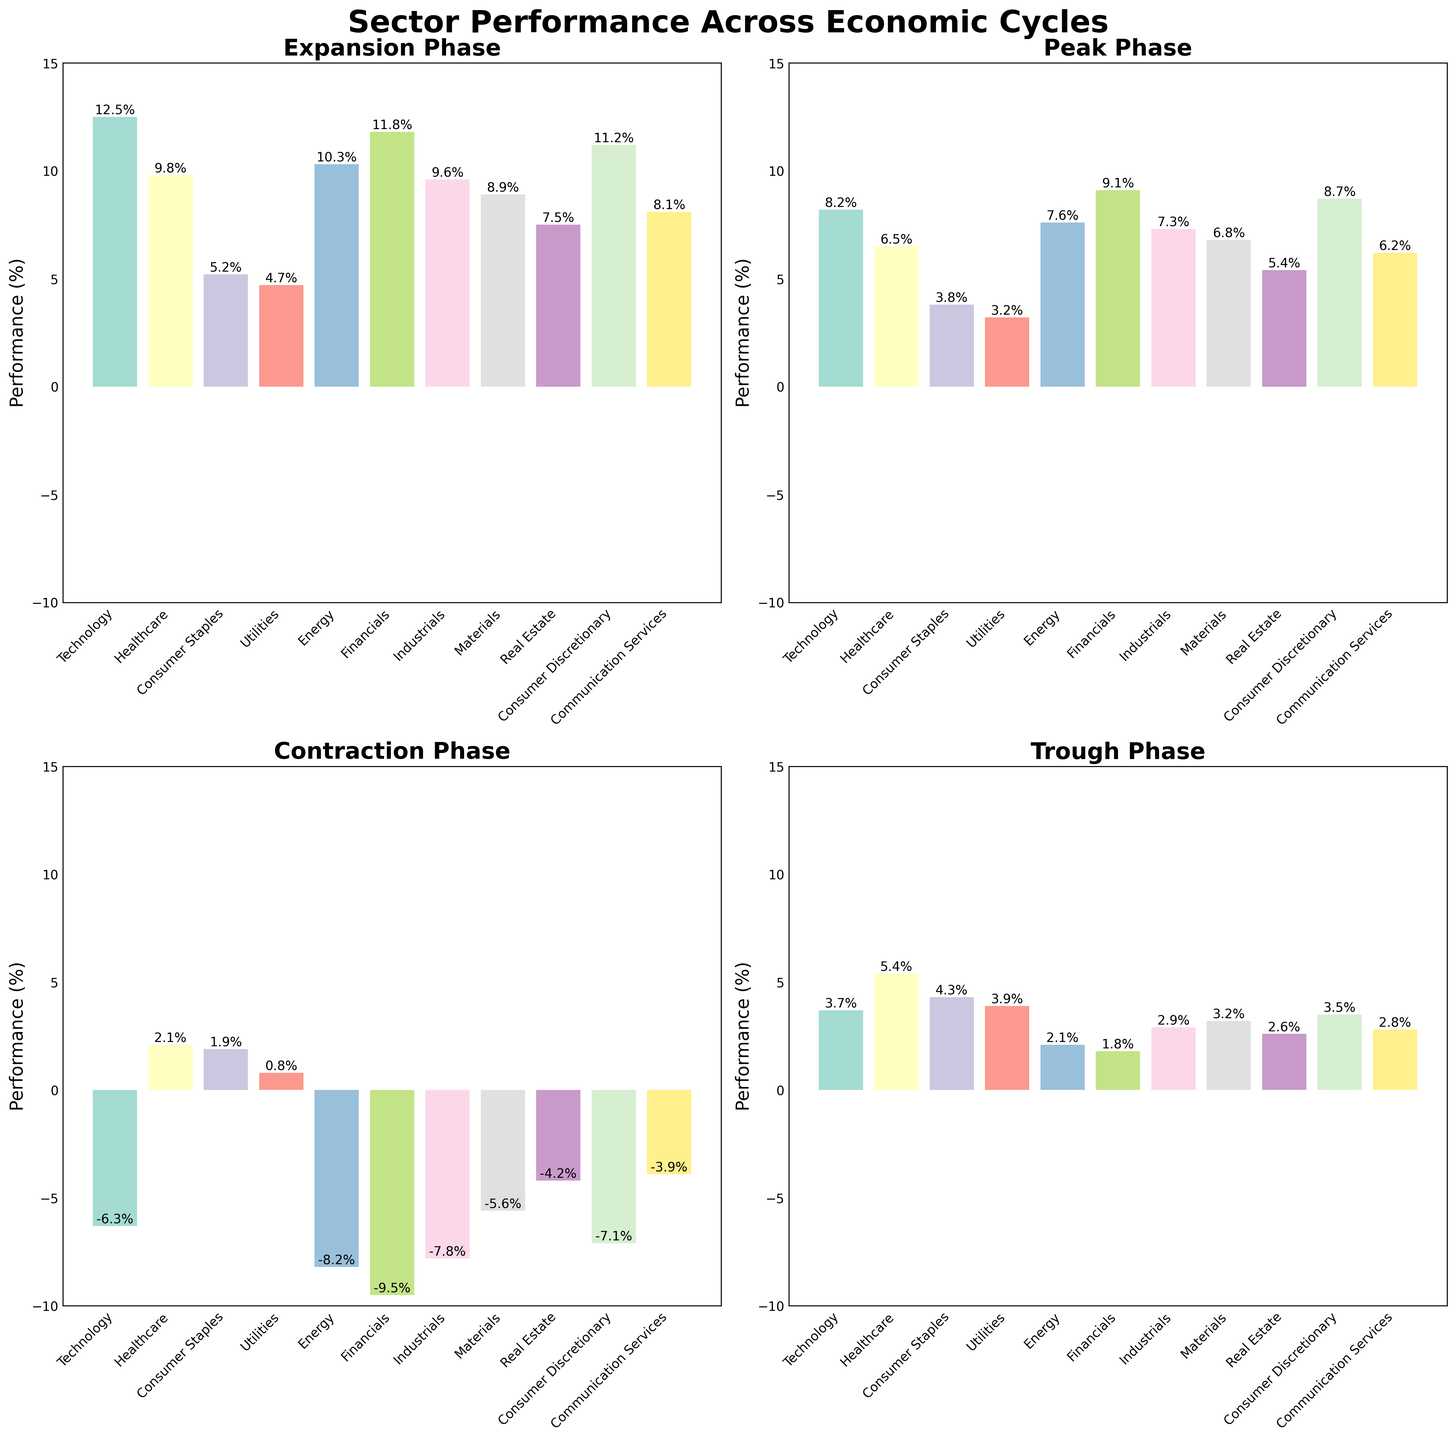Which sector performs the best during the Expansion phase? Look at the bar heights for the Expansion phase subplot. The tallest bar represents the Technology sector.
Answer: Technology Which sector has the worst performance during the Contraction phase? Look at the bar heights for the Contraction phase subplot. The bar representing Financials has the lowest value.
Answer: Financials What is the total performance of the Healthcare sector across all economic cycles? Sum up the Healthcare sector performance values across Expansion, Peak, Contraction, and Trough. (9.8 + 6.5 + 2.1 + 5.4 = 23.8)
Answer: 23.8 Which economic cycle phase shows the highest variability in sector performance? Compare the height differences across different economic cycle subplots. The Contraction phase has the widest range, with sectors spanning from -9.5% to 2.1%.
Answer: Contraction Which cycle phase has the least average performance across sectors? Calculate the average performance for each economic phase and compare them: Expansion (9.53), Peak (6.86), Contraction (-5.6), Trough (3.36). The Contraction phase has the lowest average.
Answer: Contraction Which sector shows the most consistent performance across economic cycles? Look for the sector with the smallest range in bar heights across all phases. Utilities show relatively consistent performance from 0.8% to 4.7%.
Answer: Utilities How does the performance of the Energy sector during the Contraction phase compare to its performance during the Expansion phase? Compare the bar heights for Energy in the Contraction (-8.2%) and Expansion (10.3%) phases. The Contraction phase performance is significantly lower.
Answer: Lower What is the difference in performance between the Peak and Trough phases for the Financials sector? Subtract the Trough phase performance from the Peak phase performance for Financials. (9.1 - 1.8 = 7.3)
Answer: 7.3 Which sectors show positive performance during the Contraction phase? Identify bars above the 0% line in the Contraction subplot. Positive performers are Healthcare, Consumer Staples, and Utilities.
Answer: Healthcare, Consumer Staples, Utilities During the Trough phase, which sector shows the least recovery compared to its performance during the Contraction phase? Calculate the difference for each sector between the Trough and Contraction phases. Financials shows the least improvement, from -9.5% to 1.8%.
Answer: Financials 